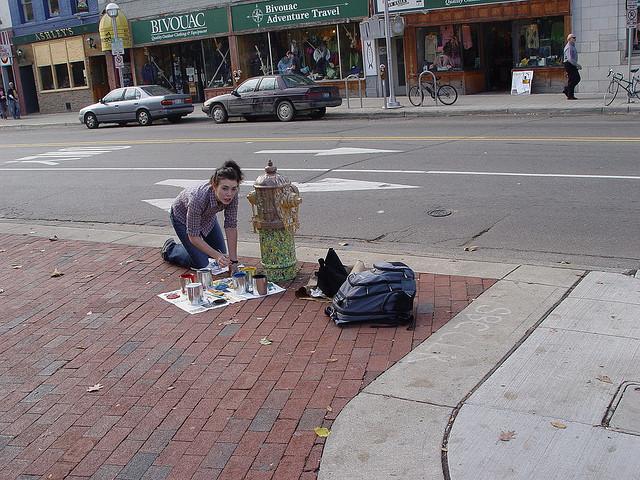What is the women doing?
Short answer required. Painting. Is this a modern or vintage photo?
Give a very brief answer. Modern. What is laying on the ground?
Answer briefly. Backpack. How many bicycles are there?
Write a very short answer. 2. Does the white object have a standard design?
Be succinct. No. How many cars are there?
Short answer required. 2. Is this the boys job?
Concise answer only. No. 